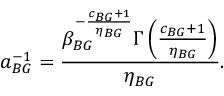Convert formula to latex. <formula><loc_0><loc_0><loc_500><loc_500>a _ { B G } ^ { - 1 } = \frac { \beta _ { B G } ^ { - \frac { c _ { B G } + 1 } { \eta _ { B G } } } \Gamma \left ( \frac { c _ { B G } + 1 } { \eta _ { B G } } \right ) } { \eta _ { B G } } .</formula> 